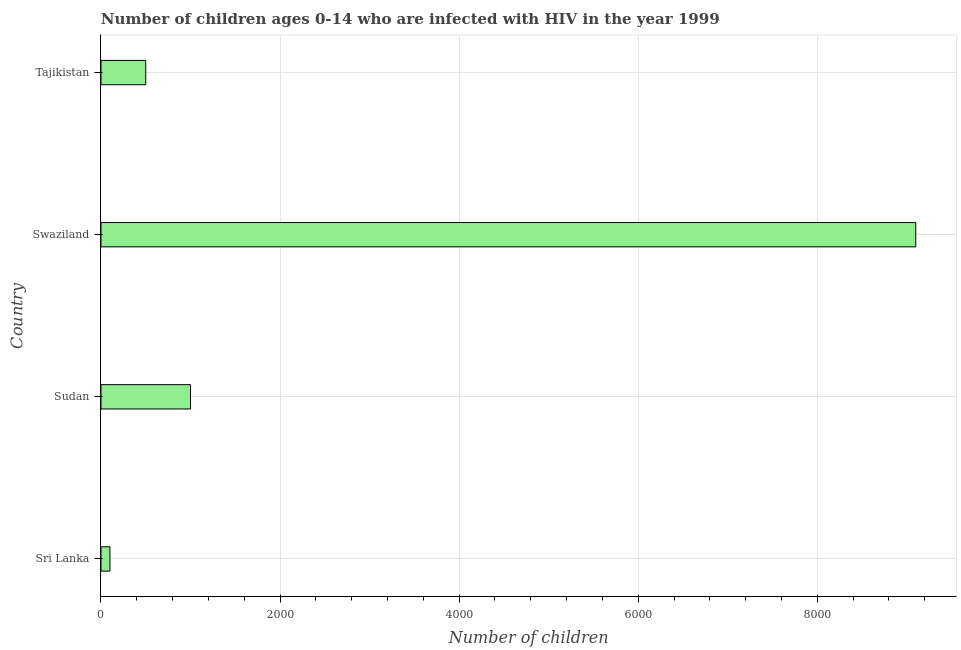What is the title of the graph?
Provide a short and direct response. Number of children ages 0-14 who are infected with HIV in the year 1999. What is the label or title of the X-axis?
Keep it short and to the point. Number of children. What is the number of children living with hiv in Swaziland?
Your answer should be very brief. 9100. Across all countries, what is the maximum number of children living with hiv?
Offer a very short reply. 9100. Across all countries, what is the minimum number of children living with hiv?
Ensure brevity in your answer.  100. In which country was the number of children living with hiv maximum?
Provide a succinct answer. Swaziland. In which country was the number of children living with hiv minimum?
Your answer should be compact. Sri Lanka. What is the sum of the number of children living with hiv?
Your answer should be compact. 1.07e+04. What is the difference between the number of children living with hiv in Sudan and Swaziland?
Ensure brevity in your answer.  -8100. What is the average number of children living with hiv per country?
Offer a very short reply. 2675. What is the median number of children living with hiv?
Ensure brevity in your answer.  750. What is the ratio of the number of children living with hiv in Sudan to that in Tajikistan?
Your answer should be compact. 2. Is the difference between the number of children living with hiv in Sri Lanka and Sudan greater than the difference between any two countries?
Keep it short and to the point. No. What is the difference between the highest and the second highest number of children living with hiv?
Give a very brief answer. 8100. Is the sum of the number of children living with hiv in Swaziland and Tajikistan greater than the maximum number of children living with hiv across all countries?
Your answer should be compact. Yes. What is the difference between the highest and the lowest number of children living with hiv?
Ensure brevity in your answer.  9000. In how many countries, is the number of children living with hiv greater than the average number of children living with hiv taken over all countries?
Provide a short and direct response. 1. How many bars are there?
Your answer should be very brief. 4. Are all the bars in the graph horizontal?
Give a very brief answer. Yes. What is the difference between two consecutive major ticks on the X-axis?
Keep it short and to the point. 2000. Are the values on the major ticks of X-axis written in scientific E-notation?
Offer a very short reply. No. What is the Number of children in Sri Lanka?
Offer a terse response. 100. What is the Number of children of Swaziland?
Make the answer very short. 9100. What is the difference between the Number of children in Sri Lanka and Sudan?
Give a very brief answer. -900. What is the difference between the Number of children in Sri Lanka and Swaziland?
Keep it short and to the point. -9000. What is the difference between the Number of children in Sri Lanka and Tajikistan?
Provide a short and direct response. -400. What is the difference between the Number of children in Sudan and Swaziland?
Your answer should be very brief. -8100. What is the difference between the Number of children in Sudan and Tajikistan?
Your response must be concise. 500. What is the difference between the Number of children in Swaziland and Tajikistan?
Ensure brevity in your answer.  8600. What is the ratio of the Number of children in Sri Lanka to that in Sudan?
Your answer should be compact. 0.1. What is the ratio of the Number of children in Sri Lanka to that in Swaziland?
Your response must be concise. 0.01. What is the ratio of the Number of children in Sudan to that in Swaziland?
Make the answer very short. 0.11. 